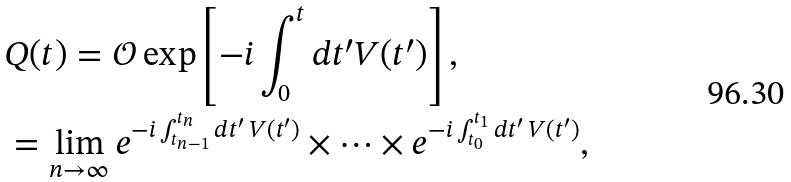<formula> <loc_0><loc_0><loc_500><loc_500>& Q ( t ) = \mathcal { O } \exp \left [ - i \int _ { 0 } ^ { t } d t ^ { \prime } V ( t ^ { \prime } ) \right ] , \\ & = \lim _ { n \to \infty } e ^ { - i \int _ { t _ { n - 1 } } ^ { t _ { n } } d t ^ { \prime } \, V ( t ^ { \prime } ) } \times \dots \times e ^ { - i \int _ { t _ { 0 } } ^ { t _ { 1 } } d t ^ { \prime } \, V ( t ^ { \prime } ) } ,</formula> 